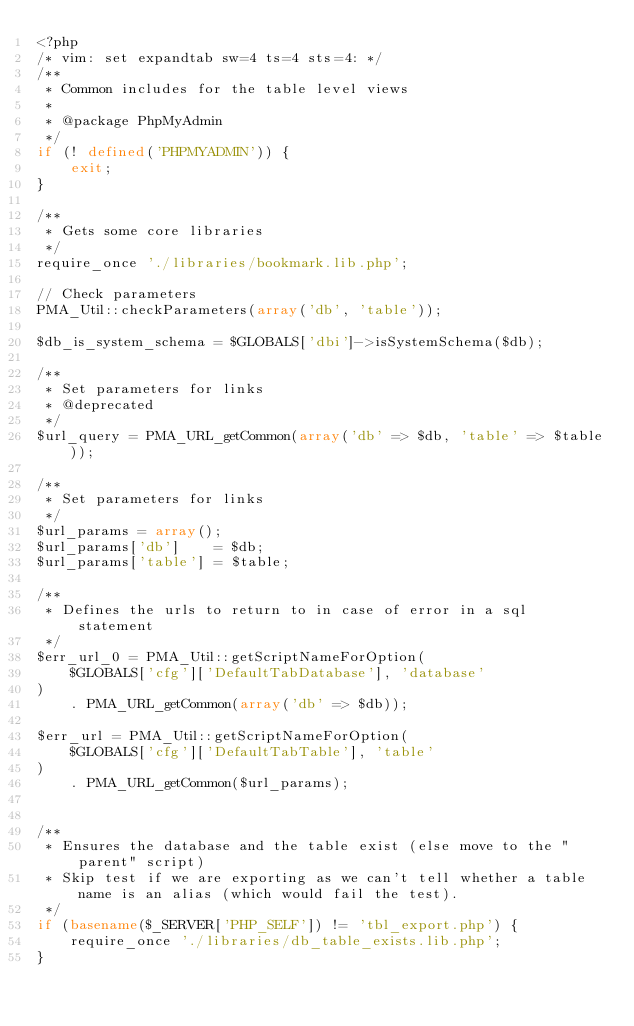Convert code to text. <code><loc_0><loc_0><loc_500><loc_500><_PHP_><?php
/* vim: set expandtab sw=4 ts=4 sts=4: */
/**
 * Common includes for the table level views
 *
 * @package PhpMyAdmin
 */
if (! defined('PHPMYADMIN')) {
    exit;
}

/**
 * Gets some core libraries
 */
require_once './libraries/bookmark.lib.php';

// Check parameters
PMA_Util::checkParameters(array('db', 'table'));

$db_is_system_schema = $GLOBALS['dbi']->isSystemSchema($db);

/**
 * Set parameters for links
 * @deprecated
 */
$url_query = PMA_URL_getCommon(array('db' => $db, 'table' => $table));

/**
 * Set parameters for links
 */
$url_params = array();
$url_params['db']    = $db;
$url_params['table'] = $table;

/**
 * Defines the urls to return to in case of error in a sql statement
 */
$err_url_0 = PMA_Util::getScriptNameForOption(
    $GLOBALS['cfg']['DefaultTabDatabase'], 'database'
)
    . PMA_URL_getCommon(array('db' => $db));

$err_url = PMA_Util::getScriptNameForOption(
    $GLOBALS['cfg']['DefaultTabTable'], 'table'
)
    . PMA_URL_getCommon($url_params);


/**
 * Ensures the database and the table exist (else move to the "parent" script)
 * Skip test if we are exporting as we can't tell whether a table name is an alias (which would fail the test).
 */
if (basename($_SERVER['PHP_SELF']) != 'tbl_export.php') {
    require_once './libraries/db_table_exists.lib.php';
}
</code> 